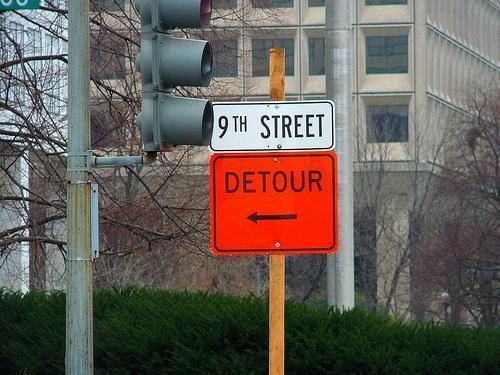How many poles do you see?
Give a very brief answer. 3. How many building are in the background?
Give a very brief answer. 2. 